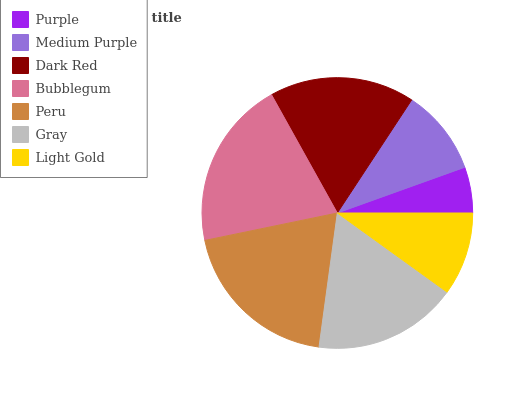Is Purple the minimum?
Answer yes or no. Yes. Is Bubblegum the maximum?
Answer yes or no. Yes. Is Medium Purple the minimum?
Answer yes or no. No. Is Medium Purple the maximum?
Answer yes or no. No. Is Medium Purple greater than Purple?
Answer yes or no. Yes. Is Purple less than Medium Purple?
Answer yes or no. Yes. Is Purple greater than Medium Purple?
Answer yes or no. No. Is Medium Purple less than Purple?
Answer yes or no. No. Is Gray the high median?
Answer yes or no. Yes. Is Gray the low median?
Answer yes or no. Yes. Is Dark Red the high median?
Answer yes or no. No. Is Medium Purple the low median?
Answer yes or no. No. 